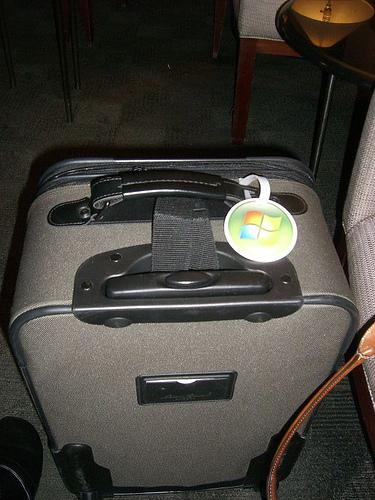How many colors in Microsoft Windows logo?

Choices:
A) six
B) one
C) five
D) four four 